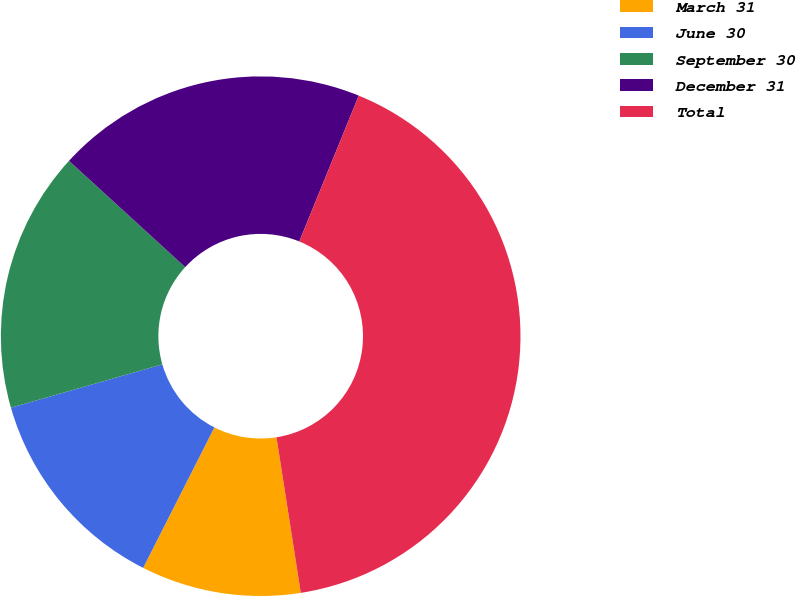Convert chart to OTSL. <chart><loc_0><loc_0><loc_500><loc_500><pie_chart><fcel>March 31<fcel>June 30<fcel>September 30<fcel>December 31<fcel>Total<nl><fcel>9.94%<fcel>13.09%<fcel>16.23%<fcel>19.37%<fcel>41.37%<nl></chart> 